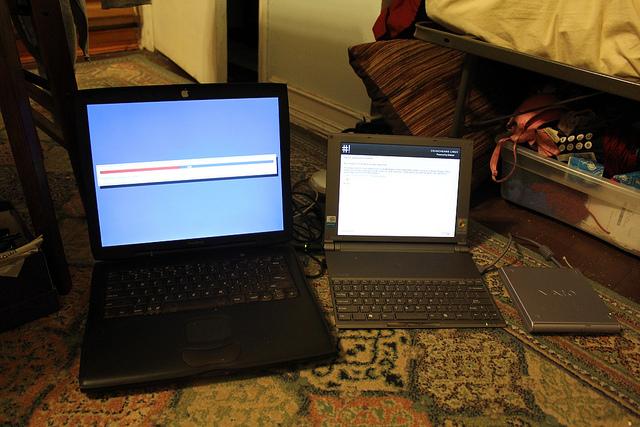How many computers?
Short answer required. 2. Are the computers powered on?
Concise answer only. Yes. Are the computers on the floor?
Short answer required. Yes. 